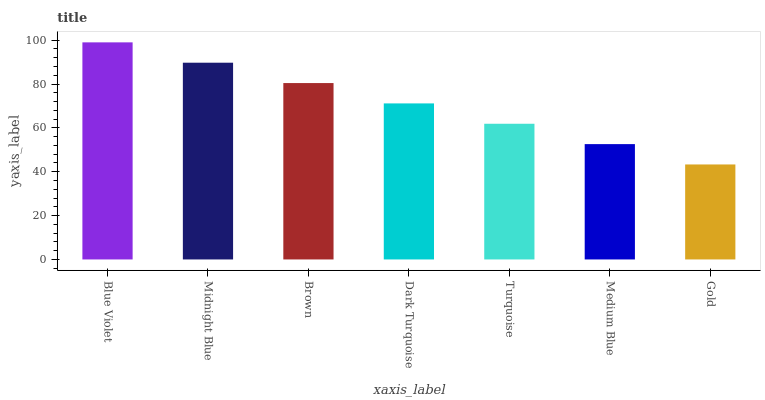Is Gold the minimum?
Answer yes or no. Yes. Is Blue Violet the maximum?
Answer yes or no. Yes. Is Midnight Blue the minimum?
Answer yes or no. No. Is Midnight Blue the maximum?
Answer yes or no. No. Is Blue Violet greater than Midnight Blue?
Answer yes or no. Yes. Is Midnight Blue less than Blue Violet?
Answer yes or no. Yes. Is Midnight Blue greater than Blue Violet?
Answer yes or no. No. Is Blue Violet less than Midnight Blue?
Answer yes or no. No. Is Dark Turquoise the high median?
Answer yes or no. Yes. Is Dark Turquoise the low median?
Answer yes or no. Yes. Is Blue Violet the high median?
Answer yes or no. No. Is Gold the low median?
Answer yes or no. No. 